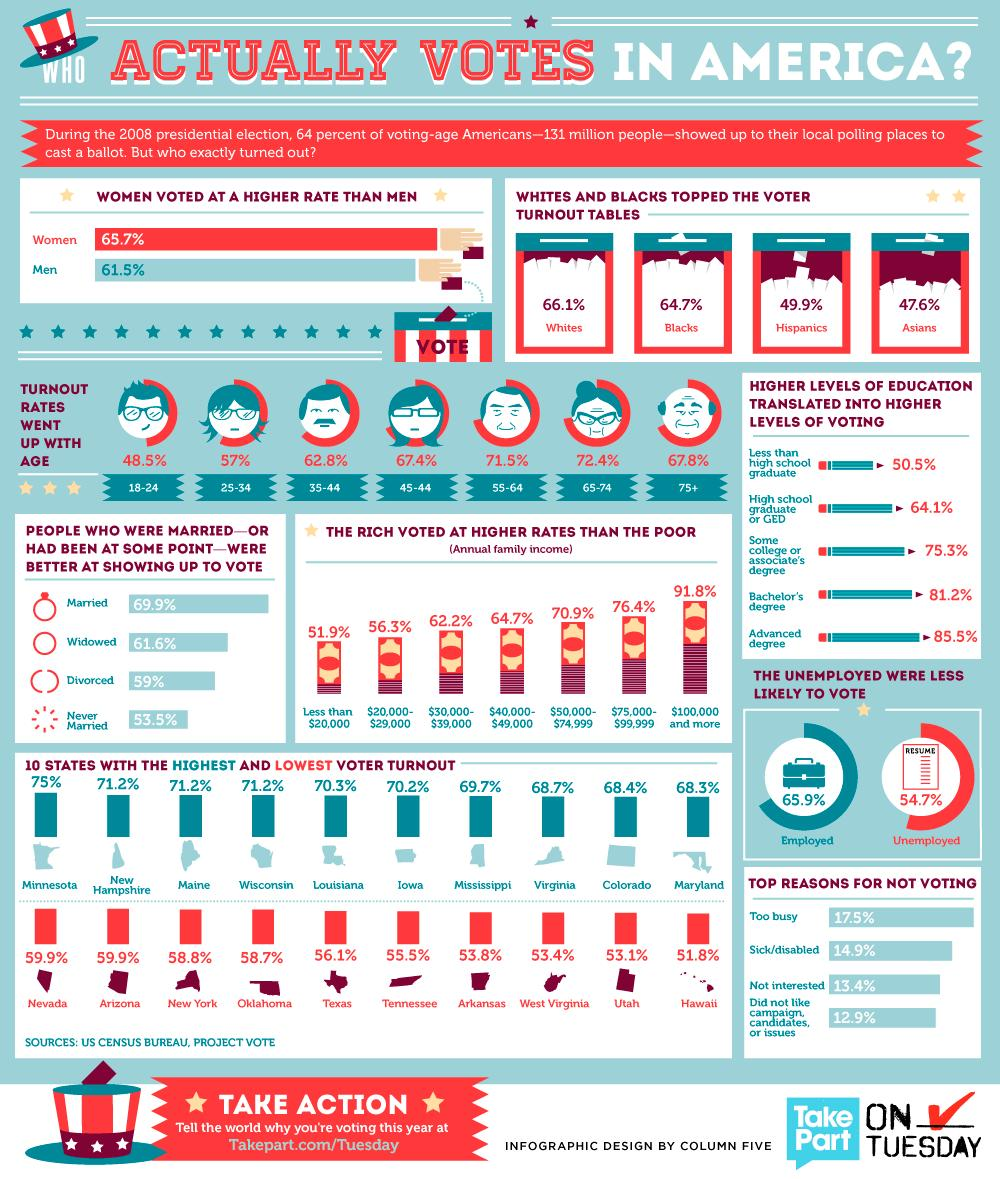Indicate a few pertinent items in this graphic. The annual income of people in America who have marked the second-highest polling is between $75,000 and $99,999. West Virginia has the third-lowest polling rate in America. Utah has the second-lowest polling rate in America. The age group of 65-74 has received the highest number of votes in the poll. The polling rate for Hispanics and Asians taken together is 97.5%. 